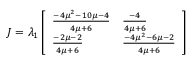Convert formula to latex. <formula><loc_0><loc_0><loc_500><loc_500>J = \lambda _ { 1 } \left [ \begin{array} { l l } { \frac { - 4 \mu ^ { 2 } - 1 0 \mu - 4 } { 4 \mu + 6 } } & { \frac { - 4 } { 4 \mu + 6 } } \\ { \frac { - 2 \mu - 2 } { 4 \mu + 6 } } & { \frac { - 4 \mu ^ { 2 } - 6 \mu - 2 } { 4 \mu + 6 } } \end{array} \right ]</formula> 